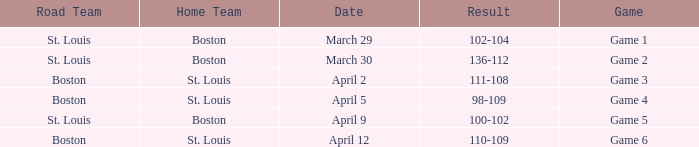What is the Game number on March 30? Game 2. 